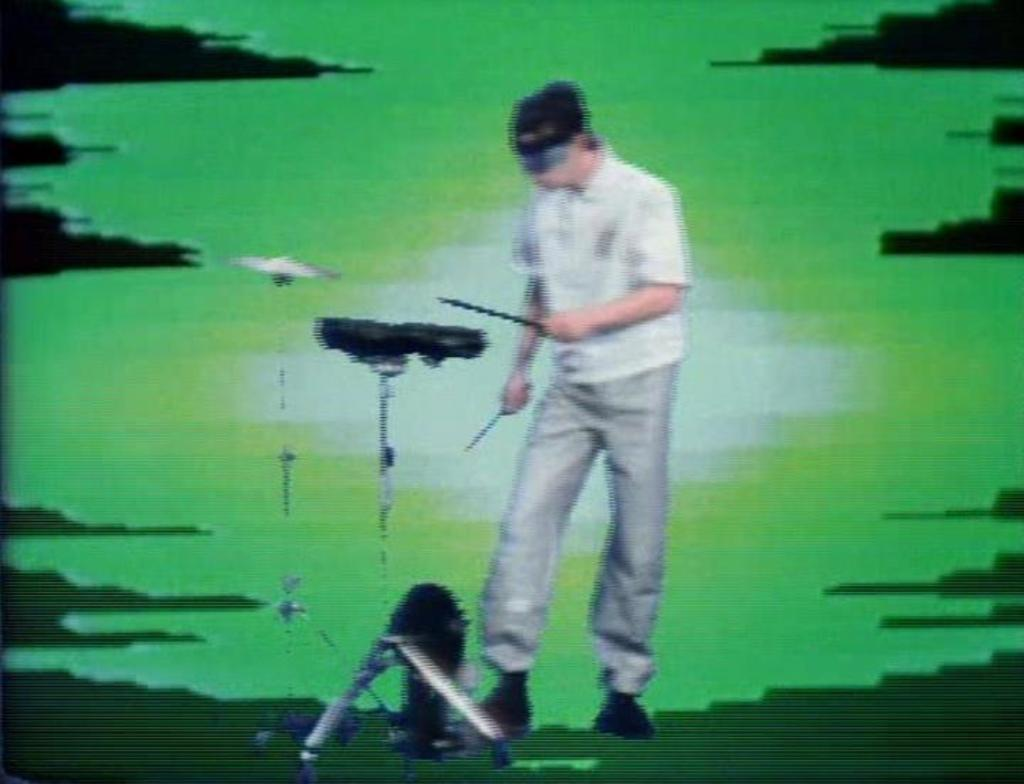What is the main subject of the image? There is a person in the image. What is the person holding in the image? The person is holding a musical instrument. Can you describe the person's clothing in the image? The person is wearing a white shirt. What type of feast is being prepared by the person in the image? There is no indication of a feast or any food preparation in the image. How many lizards can be seen on the person's shoulder in the image? There are no lizards present in the image. 